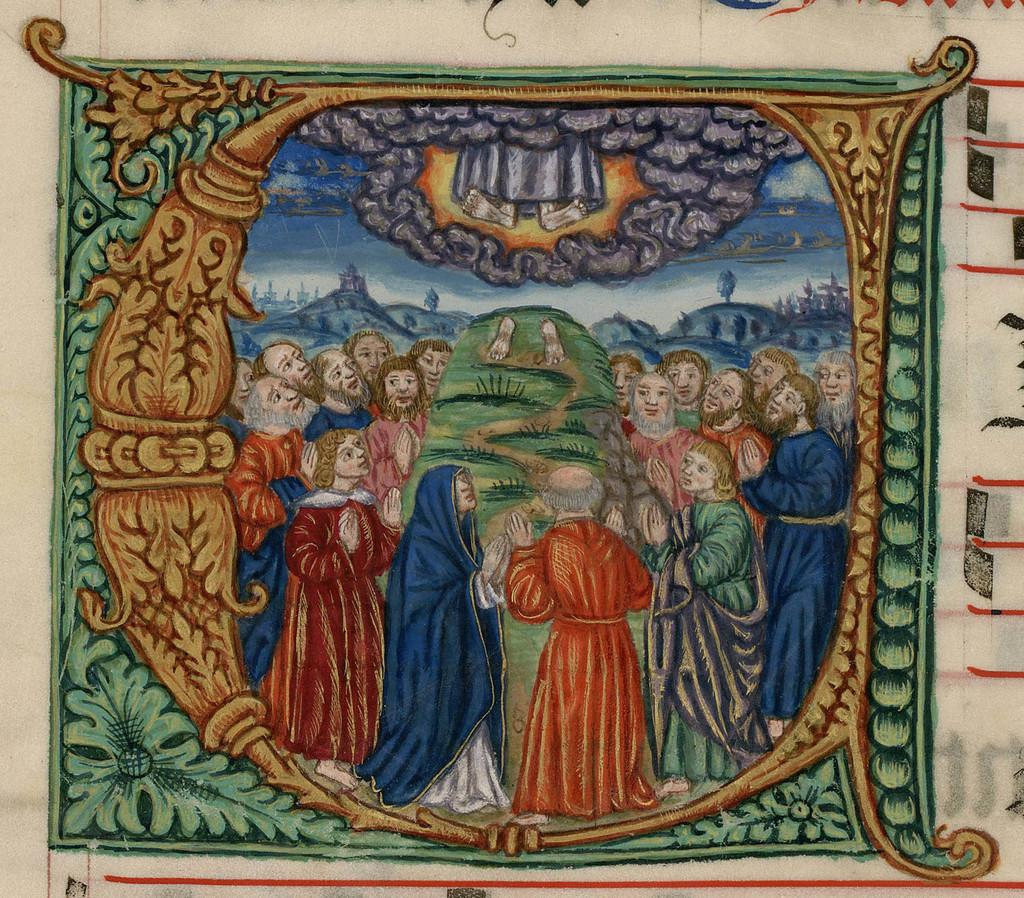What is the main subject of the wall painting in the image? The wall painting depicts a group of people standing on the ground. What type of terrain is visible in the wall painting? Grass is visible in the wall painting. What type of structures are depicted in the wall painting? Houses are depicted in the wall painting. What is visible in the sky in the wall painting? The sky is visible in the wall painting. How many dimes are scattered on the ground in the wall painting? There are no dimes visible in the wall painting; it depicts a group of people standing on the ground with grass, houses, and the sky. 